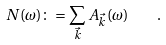<formula> <loc_0><loc_0><loc_500><loc_500>N ( \omega ) \colon = \sum _ { \vec { k } } A _ { \vec { k } } ( \omega ) \quad .</formula> 